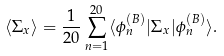<formula> <loc_0><loc_0><loc_500><loc_500>\langle \Sigma _ { x } \rangle = \frac { 1 } { 2 0 } \sum _ { n = 1 } ^ { 2 0 } \langle \phi _ { n } ^ { ( B ) } | \Sigma _ { x } | \phi _ { n } ^ { ( B ) } \rangle .</formula> 